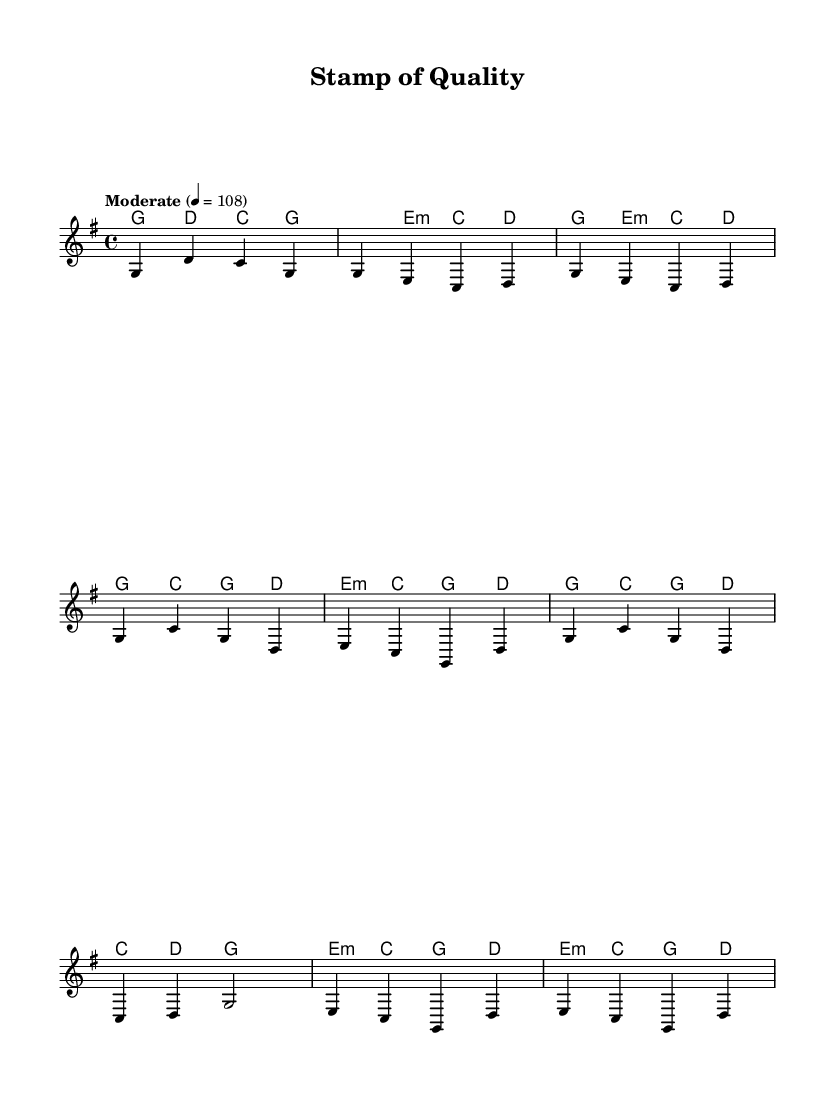What is the key signature of this music? The key signature is indicated at the beginning of the staff, which shows that there are no sharps or flats. This denotes that the piece is in G major, which includes an F# as the only sharp.
Answer: G major What is the time signature of this music? The time signature is found at the beginning of the score and is displayed as 4/4, meaning there are four beats in each measure and the quarter note gets one beat.
Answer: 4/4 What is the tempo marking for the piece? The tempo marking is indicated in the score and specifies "Moderate" with a tempo of 108 beats per minute, which guides the performers on how fast to play.
Answer: Moderate 4 = 108 How many measures are in the chorus section? By counting the measures labeled in the chorus section, we find there are four distinct measures in the chorus part of the music.
Answer: 4 What is the primary chord used in the intro? The intro section consistently uses the chords G, D, and C, with G being the first chord in this part.
Answer: G What is the last note of the bridge section? In the bridge section, the last note played is a D that is held for two beats, marking the conclusion of that section.
Answer: D Which chord is most frequently used in the verse? In the verse, the chords G major and E minor are both present; however, G major appears more frequently across the two lines of the verse.
Answer: G 